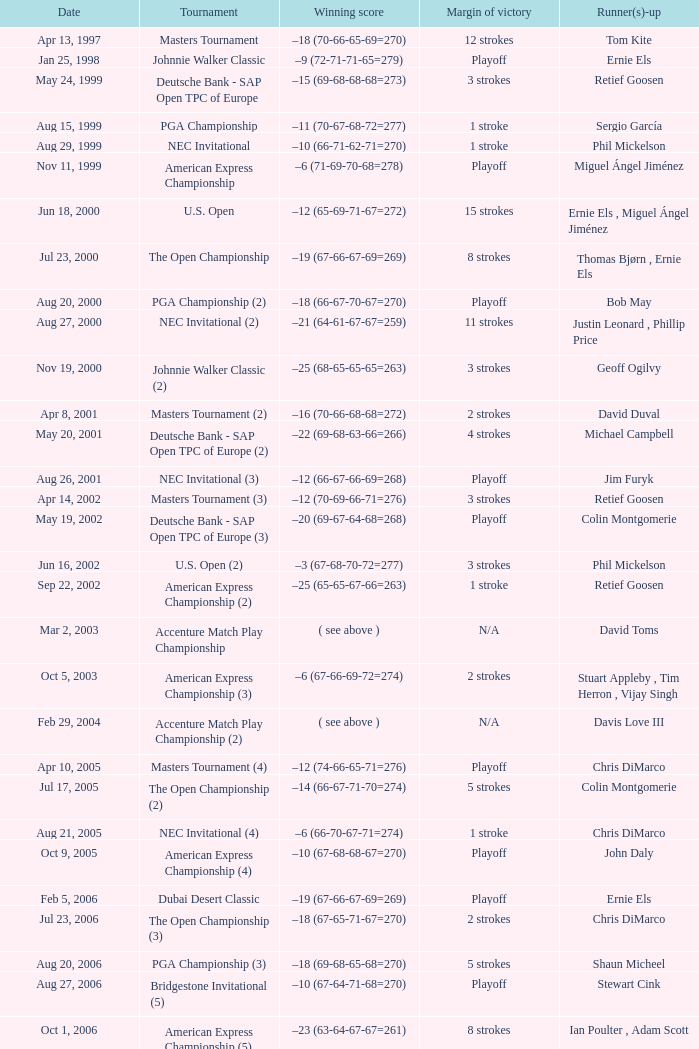Write the full table. {'header': ['Date', 'Tournament', 'Winning score', 'Margin of victory', 'Runner(s)-up'], 'rows': [['Apr 13, 1997', 'Masters Tournament', '–18 (70-66-65-69=270)', '12 strokes', 'Tom Kite'], ['Jan 25, 1998', 'Johnnie Walker Classic', '–9 (72-71-71-65=279)', 'Playoff', 'Ernie Els'], ['May 24, 1999', 'Deutsche Bank - SAP Open TPC of Europe', '–15 (69-68-68-68=273)', '3 strokes', 'Retief Goosen'], ['Aug 15, 1999', 'PGA Championship', '–11 (70-67-68-72=277)', '1 stroke', 'Sergio García'], ['Aug 29, 1999', 'NEC Invitational', '–10 (66-71-62-71=270)', '1 stroke', 'Phil Mickelson'], ['Nov 11, 1999', 'American Express Championship', '–6 (71-69-70-68=278)', 'Playoff', 'Miguel Ángel Jiménez'], ['Jun 18, 2000', 'U.S. Open', '–12 (65-69-71-67=272)', '15 strokes', 'Ernie Els , Miguel Ángel Jiménez'], ['Jul 23, 2000', 'The Open Championship', '–19 (67-66-67-69=269)', '8 strokes', 'Thomas Bjørn , Ernie Els'], ['Aug 20, 2000', 'PGA Championship (2)', '–18 (66-67-70-67=270)', 'Playoff', 'Bob May'], ['Aug 27, 2000', 'NEC Invitational (2)', '–21 (64-61-67-67=259)', '11 strokes', 'Justin Leonard , Phillip Price'], ['Nov 19, 2000', 'Johnnie Walker Classic (2)', '–25 (68-65-65-65=263)', '3 strokes', 'Geoff Ogilvy'], ['Apr 8, 2001', 'Masters Tournament (2)', '–16 (70-66-68-68=272)', '2 strokes', 'David Duval'], ['May 20, 2001', 'Deutsche Bank - SAP Open TPC of Europe (2)', '–22 (69-68-63-66=266)', '4 strokes', 'Michael Campbell'], ['Aug 26, 2001', 'NEC Invitational (3)', '–12 (66-67-66-69=268)', 'Playoff', 'Jim Furyk'], ['Apr 14, 2002', 'Masters Tournament (3)', '–12 (70-69-66-71=276)', '3 strokes', 'Retief Goosen'], ['May 19, 2002', 'Deutsche Bank - SAP Open TPC of Europe (3)', '–20 (69-67-64-68=268)', 'Playoff', 'Colin Montgomerie'], ['Jun 16, 2002', 'U.S. Open (2)', '–3 (67-68-70-72=277)', '3 strokes', 'Phil Mickelson'], ['Sep 22, 2002', 'American Express Championship (2)', '–25 (65-65-67-66=263)', '1 stroke', 'Retief Goosen'], ['Mar 2, 2003', 'Accenture Match Play Championship', '( see above )', 'N/A', 'David Toms'], ['Oct 5, 2003', 'American Express Championship (3)', '–6 (67-66-69-72=274)', '2 strokes', 'Stuart Appleby , Tim Herron , Vijay Singh'], ['Feb 29, 2004', 'Accenture Match Play Championship (2)', '( see above )', 'N/A', 'Davis Love III'], ['Apr 10, 2005', 'Masters Tournament (4)', '–12 (74-66-65-71=276)', 'Playoff', 'Chris DiMarco'], ['Jul 17, 2005', 'The Open Championship (2)', '–14 (66-67-71-70=274)', '5 strokes', 'Colin Montgomerie'], ['Aug 21, 2005', 'NEC Invitational (4)', '–6 (66-70-67-71=274)', '1 stroke', 'Chris DiMarco'], ['Oct 9, 2005', 'American Express Championship (4)', '–10 (67-68-68-67=270)', 'Playoff', 'John Daly'], ['Feb 5, 2006', 'Dubai Desert Classic', '–19 (67-66-67-69=269)', 'Playoff', 'Ernie Els'], ['Jul 23, 2006', 'The Open Championship (3)', '–18 (67-65-71-67=270)', '2 strokes', 'Chris DiMarco'], ['Aug 20, 2006', 'PGA Championship (3)', '–18 (69-68-65-68=270)', '5 strokes', 'Shaun Micheel'], ['Aug 27, 2006', 'Bridgestone Invitational (5)', '–10 (67-64-71-68=270)', 'Playoff', 'Stewart Cink'], ['Oct 1, 2006', 'American Express Championship (5)', '–23 (63-64-67-67=261)', '8 strokes', 'Ian Poulter , Adam Scott'], ['Mar 25, 2007', 'CA Championship (6)', '–10 (71-66-68-73=278)', '2 strokes', 'Brett Wetterich'], ['Aug 5, 2007', 'Bridgestone Invitational (6)', '−8 (68-70-69-65=272)', '8 strokes', 'Justin Rose , Rory Sabbatini'], ['Aug 12, 2007', 'PGA Championship (4)', '–8 (71-63-69-69=272)', '2 strokes', 'Woody Austin'], ['Feb 3, 2008', 'Dubai Desert Classic (2)', '–14 (65-71-73-65=274)', '1 stroke', 'Martin Kaymer'], ['Feb 24, 2008', 'Accenture Match Play Championship (3)', '( see above )', 'N/A', 'Stewart Cink'], ['Jun 16, 2008', 'U.S. Open (3)', '–1 (72-68-70-73=283)', 'Playoff', 'Rocco Mediate'], ['Aug 9, 2009', 'Bridgestone Invitational (7)', '−12 (68-70-65-65=268)', '4 strokes', 'Robert Allenby , Pádraig Harrington'], ['Nov 15, 2009', 'JBWere Masters', '–14 (66-68-72-68=274)', '2 strokes', 'Greg Chalmers'], ['Mar 10, 2013', 'Cadillac Championship (7)', '–19 (66-65-67-71=269)', '2 strokes', 'Steve Stricker'], ['Aug 4, 2013', 'Bridgestone Invitational (8)', '−15 (66-61-68-70=265)', '7 strokes', 'Keegan Bradley , Henrik Stenson']]} Who has the Winning score of –10 (66-71-62-71=270) ? Phil Mickelson. 